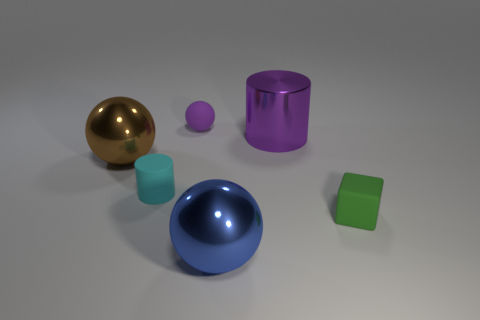What number of other objects are the same shape as the small cyan thing?
Offer a terse response. 1. There is a cylinder to the left of the purple ball; are there any large metal spheres in front of it?
Offer a very short reply. Yes. How many big yellow cylinders are there?
Ensure brevity in your answer.  0. Does the large cylinder have the same color as the tiny object behind the purple cylinder?
Keep it short and to the point. Yes. Are there more purple matte things than small yellow objects?
Your answer should be very brief. Yes. Is there anything else of the same color as the large metal cylinder?
Your answer should be compact. Yes. What material is the big ball behind the tiny thing that is right of the large metallic thing that is in front of the small matte block?
Your response must be concise. Metal. Are the tiny cyan cylinder and the cube behind the big blue ball made of the same material?
Make the answer very short. Yes. Are there fewer tiny cubes left of the small ball than purple balls behind the green matte object?
Make the answer very short. Yes. How many tiny green blocks are made of the same material as the cyan cylinder?
Give a very brief answer. 1. 